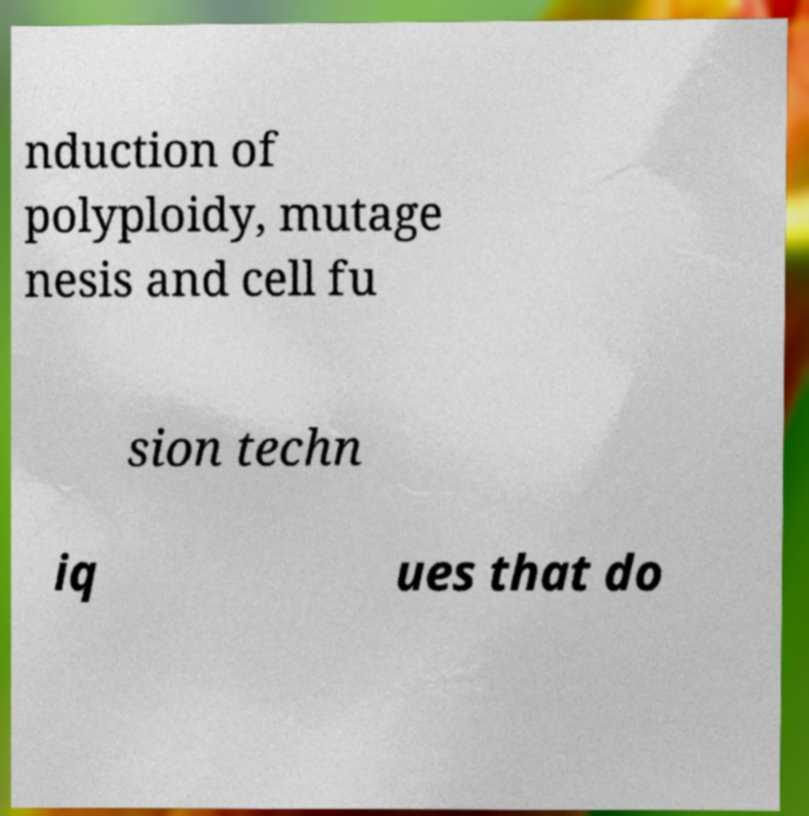I need the written content from this picture converted into text. Can you do that? nduction of polyploidy, mutage nesis and cell fu sion techn iq ues that do 